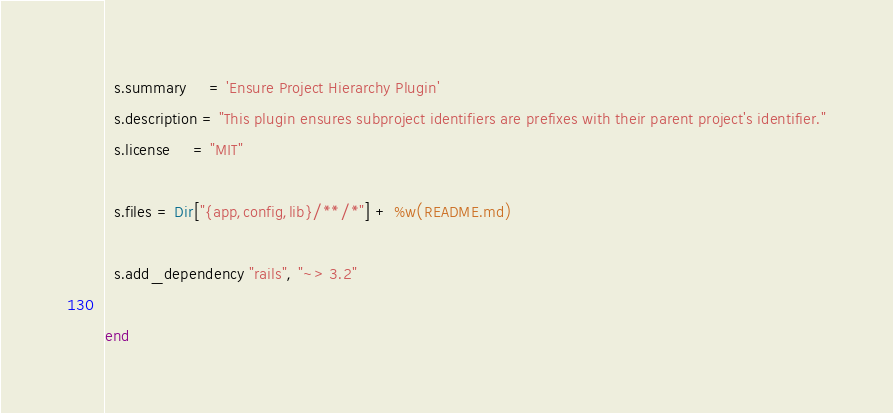Convert code to text. <code><loc_0><loc_0><loc_500><loc_500><_Ruby_>  s.summary     = 'Ensure Project Hierarchy Plugin'
  s.description = "This plugin ensures subproject identifiers are prefixes with their parent project's identifier."
  s.license     = "MIT"

  s.files = Dir["{app,config,lib}/**/*"] + %w(README.md)

  s.add_dependency "rails", "~> 3.2"

end
</code> 